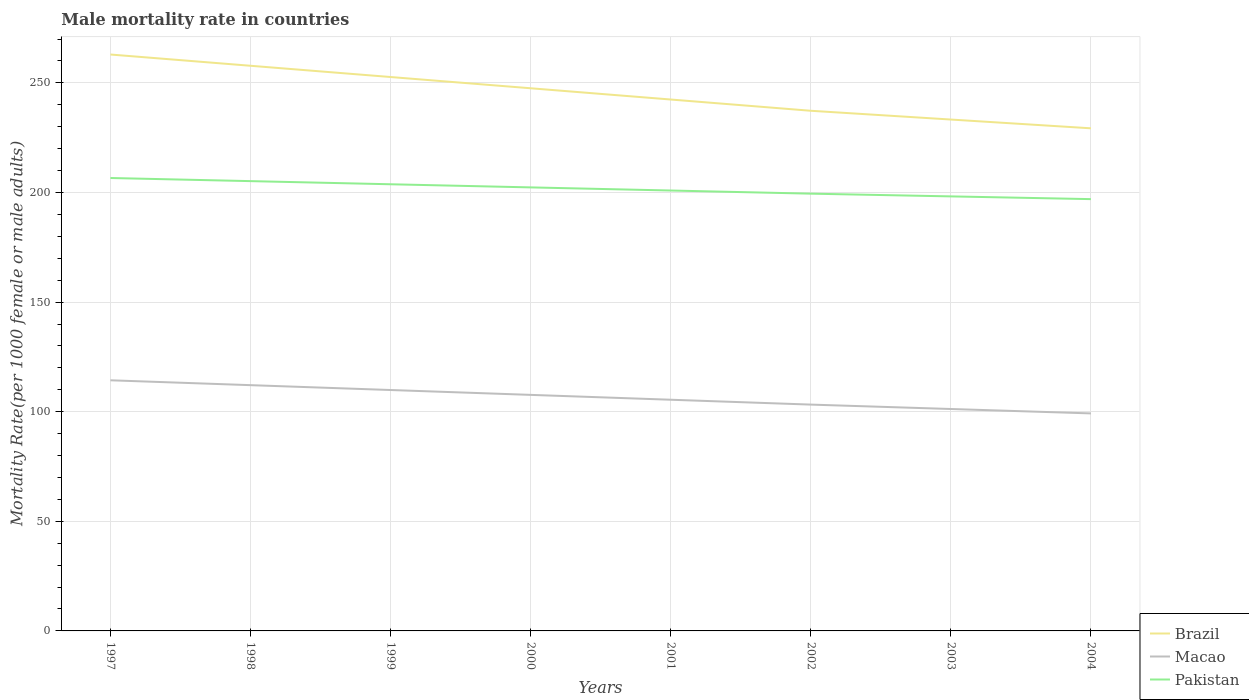Across all years, what is the maximum male mortality rate in Brazil?
Make the answer very short. 229.27. What is the total male mortality rate in Macao in the graph?
Offer a very short reply. 6.24. What is the difference between the highest and the second highest male mortality rate in Brazil?
Your answer should be very brief. 33.66. Is the male mortality rate in Macao strictly greater than the male mortality rate in Brazil over the years?
Give a very brief answer. Yes. How many lines are there?
Offer a terse response. 3. How many years are there in the graph?
Provide a short and direct response. 8. What is the difference between two consecutive major ticks on the Y-axis?
Provide a short and direct response. 50. Does the graph contain any zero values?
Offer a very short reply. No. Does the graph contain grids?
Ensure brevity in your answer.  Yes. Where does the legend appear in the graph?
Provide a short and direct response. Bottom right. How many legend labels are there?
Your response must be concise. 3. How are the legend labels stacked?
Ensure brevity in your answer.  Vertical. What is the title of the graph?
Provide a succinct answer. Male mortality rate in countries. Does "United Arab Emirates" appear as one of the legend labels in the graph?
Keep it short and to the point. No. What is the label or title of the X-axis?
Keep it short and to the point. Years. What is the label or title of the Y-axis?
Provide a short and direct response. Mortality Rate(per 1000 female or male adults). What is the Mortality Rate(per 1000 female or male adults) of Brazil in 1997?
Provide a short and direct response. 262.93. What is the Mortality Rate(per 1000 female or male adults) of Macao in 1997?
Make the answer very short. 114.33. What is the Mortality Rate(per 1000 female or male adults) in Pakistan in 1997?
Provide a succinct answer. 206.6. What is the Mortality Rate(per 1000 female or male adults) in Brazil in 1998?
Your answer should be compact. 257.79. What is the Mortality Rate(per 1000 female or male adults) of Macao in 1998?
Offer a very short reply. 112.11. What is the Mortality Rate(per 1000 female or male adults) of Pakistan in 1998?
Keep it short and to the point. 205.17. What is the Mortality Rate(per 1000 female or male adults) of Brazil in 1999?
Your answer should be very brief. 252.66. What is the Mortality Rate(per 1000 female or male adults) of Macao in 1999?
Your answer should be very brief. 109.89. What is the Mortality Rate(per 1000 female or male adults) in Pakistan in 1999?
Keep it short and to the point. 203.75. What is the Mortality Rate(per 1000 female or male adults) of Brazil in 2000?
Offer a very short reply. 247.53. What is the Mortality Rate(per 1000 female or male adults) of Macao in 2000?
Your answer should be very brief. 107.67. What is the Mortality Rate(per 1000 female or male adults) in Pakistan in 2000?
Ensure brevity in your answer.  202.32. What is the Mortality Rate(per 1000 female or male adults) of Brazil in 2001?
Your response must be concise. 242.4. What is the Mortality Rate(per 1000 female or male adults) in Macao in 2001?
Your answer should be very brief. 105.46. What is the Mortality Rate(per 1000 female or male adults) of Pakistan in 2001?
Your answer should be very brief. 200.89. What is the Mortality Rate(per 1000 female or male adults) of Brazil in 2002?
Your response must be concise. 237.27. What is the Mortality Rate(per 1000 female or male adults) of Macao in 2002?
Your response must be concise. 103.24. What is the Mortality Rate(per 1000 female or male adults) in Pakistan in 2002?
Offer a terse response. 199.46. What is the Mortality Rate(per 1000 female or male adults) of Brazil in 2003?
Make the answer very short. 233.27. What is the Mortality Rate(per 1000 female or male adults) of Macao in 2003?
Your answer should be very brief. 101.23. What is the Mortality Rate(per 1000 female or male adults) in Pakistan in 2003?
Keep it short and to the point. 198.21. What is the Mortality Rate(per 1000 female or male adults) of Brazil in 2004?
Provide a short and direct response. 229.27. What is the Mortality Rate(per 1000 female or male adults) in Macao in 2004?
Your answer should be very brief. 99.22. What is the Mortality Rate(per 1000 female or male adults) in Pakistan in 2004?
Offer a terse response. 196.97. Across all years, what is the maximum Mortality Rate(per 1000 female or male adults) of Brazil?
Your answer should be very brief. 262.93. Across all years, what is the maximum Mortality Rate(per 1000 female or male adults) in Macao?
Your answer should be compact. 114.33. Across all years, what is the maximum Mortality Rate(per 1000 female or male adults) of Pakistan?
Your response must be concise. 206.6. Across all years, what is the minimum Mortality Rate(per 1000 female or male adults) in Brazil?
Your answer should be very brief. 229.27. Across all years, what is the minimum Mortality Rate(per 1000 female or male adults) in Macao?
Offer a very short reply. 99.22. Across all years, what is the minimum Mortality Rate(per 1000 female or male adults) in Pakistan?
Offer a very short reply. 196.97. What is the total Mortality Rate(per 1000 female or male adults) in Brazil in the graph?
Provide a succinct answer. 1963.11. What is the total Mortality Rate(per 1000 female or male adults) of Macao in the graph?
Offer a very short reply. 853.14. What is the total Mortality Rate(per 1000 female or male adults) of Pakistan in the graph?
Provide a short and direct response. 1613.36. What is the difference between the Mortality Rate(per 1000 female or male adults) in Brazil in 1997 and that in 1998?
Keep it short and to the point. 5.13. What is the difference between the Mortality Rate(per 1000 female or male adults) of Macao in 1997 and that in 1998?
Your answer should be compact. 2.22. What is the difference between the Mortality Rate(per 1000 female or male adults) in Pakistan in 1997 and that in 1998?
Your answer should be compact. 1.43. What is the difference between the Mortality Rate(per 1000 female or male adults) of Brazil in 1997 and that in 1999?
Your answer should be compact. 10.26. What is the difference between the Mortality Rate(per 1000 female or male adults) of Macao in 1997 and that in 1999?
Offer a terse response. 4.43. What is the difference between the Mortality Rate(per 1000 female or male adults) in Pakistan in 1997 and that in 1999?
Your answer should be very brief. 2.86. What is the difference between the Mortality Rate(per 1000 female or male adults) of Brazil in 1997 and that in 2000?
Offer a terse response. 15.39. What is the difference between the Mortality Rate(per 1000 female or male adults) of Macao in 1997 and that in 2000?
Offer a very short reply. 6.65. What is the difference between the Mortality Rate(per 1000 female or male adults) in Pakistan in 1997 and that in 2000?
Your answer should be very brief. 4.28. What is the difference between the Mortality Rate(per 1000 female or male adults) of Brazil in 1997 and that in 2001?
Your answer should be compact. 20.53. What is the difference between the Mortality Rate(per 1000 female or male adults) in Macao in 1997 and that in 2001?
Provide a succinct answer. 8.87. What is the difference between the Mortality Rate(per 1000 female or male adults) of Pakistan in 1997 and that in 2001?
Your answer should be very brief. 5.71. What is the difference between the Mortality Rate(per 1000 female or male adults) of Brazil in 1997 and that in 2002?
Your answer should be compact. 25.66. What is the difference between the Mortality Rate(per 1000 female or male adults) in Macao in 1997 and that in 2002?
Offer a terse response. 11.09. What is the difference between the Mortality Rate(per 1000 female or male adults) in Pakistan in 1997 and that in 2002?
Make the answer very short. 7.14. What is the difference between the Mortality Rate(per 1000 female or male adults) of Brazil in 1997 and that in 2003?
Offer a very short reply. 29.66. What is the difference between the Mortality Rate(per 1000 female or male adults) in Macao in 1997 and that in 2003?
Make the answer very short. 13.1. What is the difference between the Mortality Rate(per 1000 female or male adults) of Pakistan in 1997 and that in 2003?
Your answer should be compact. 8.39. What is the difference between the Mortality Rate(per 1000 female or male adults) of Brazil in 1997 and that in 2004?
Offer a terse response. 33.66. What is the difference between the Mortality Rate(per 1000 female or male adults) in Macao in 1997 and that in 2004?
Give a very brief answer. 15.11. What is the difference between the Mortality Rate(per 1000 female or male adults) in Pakistan in 1997 and that in 2004?
Make the answer very short. 9.64. What is the difference between the Mortality Rate(per 1000 female or male adults) of Brazil in 1998 and that in 1999?
Provide a succinct answer. 5.13. What is the difference between the Mortality Rate(per 1000 female or male adults) of Macao in 1998 and that in 1999?
Offer a very short reply. 2.22. What is the difference between the Mortality Rate(per 1000 female or male adults) in Pakistan in 1998 and that in 1999?
Provide a succinct answer. 1.43. What is the difference between the Mortality Rate(per 1000 female or male adults) of Brazil in 1998 and that in 2000?
Give a very brief answer. 10.26. What is the difference between the Mortality Rate(per 1000 female or male adults) in Macao in 1998 and that in 2000?
Offer a very short reply. 4.43. What is the difference between the Mortality Rate(per 1000 female or male adults) in Pakistan in 1998 and that in 2000?
Provide a short and direct response. 2.86. What is the difference between the Mortality Rate(per 1000 female or male adults) in Brazil in 1998 and that in 2001?
Offer a terse response. 15.39. What is the difference between the Mortality Rate(per 1000 female or male adults) of Macao in 1998 and that in 2001?
Your answer should be compact. 6.65. What is the difference between the Mortality Rate(per 1000 female or male adults) in Pakistan in 1998 and that in 2001?
Your answer should be compact. 4.28. What is the difference between the Mortality Rate(per 1000 female or male adults) of Brazil in 1998 and that in 2002?
Offer a terse response. 20.53. What is the difference between the Mortality Rate(per 1000 female or male adults) of Macao in 1998 and that in 2002?
Offer a terse response. 8.87. What is the difference between the Mortality Rate(per 1000 female or male adults) of Pakistan in 1998 and that in 2002?
Ensure brevity in your answer.  5.71. What is the difference between the Mortality Rate(per 1000 female or male adults) in Brazil in 1998 and that in 2003?
Ensure brevity in your answer.  24.53. What is the difference between the Mortality Rate(per 1000 female or male adults) of Macao in 1998 and that in 2003?
Your answer should be compact. 10.88. What is the difference between the Mortality Rate(per 1000 female or male adults) in Pakistan in 1998 and that in 2003?
Ensure brevity in your answer.  6.96. What is the difference between the Mortality Rate(per 1000 female or male adults) of Brazil in 1998 and that in 2004?
Keep it short and to the point. 28.53. What is the difference between the Mortality Rate(per 1000 female or male adults) in Macao in 1998 and that in 2004?
Provide a short and direct response. 12.89. What is the difference between the Mortality Rate(per 1000 female or male adults) of Pakistan in 1998 and that in 2004?
Offer a terse response. 8.21. What is the difference between the Mortality Rate(per 1000 female or male adults) in Brazil in 1999 and that in 2000?
Your answer should be compact. 5.13. What is the difference between the Mortality Rate(per 1000 female or male adults) of Macao in 1999 and that in 2000?
Your answer should be compact. 2.22. What is the difference between the Mortality Rate(per 1000 female or male adults) in Pakistan in 1999 and that in 2000?
Offer a terse response. 1.43. What is the difference between the Mortality Rate(per 1000 female or male adults) of Brazil in 1999 and that in 2001?
Your response must be concise. 10.26. What is the difference between the Mortality Rate(per 1000 female or male adults) in Macao in 1999 and that in 2001?
Offer a terse response. 4.43. What is the difference between the Mortality Rate(per 1000 female or male adults) in Pakistan in 1999 and that in 2001?
Your response must be concise. 2.86. What is the difference between the Mortality Rate(per 1000 female or male adults) of Brazil in 1999 and that in 2002?
Your response must be concise. 15.39. What is the difference between the Mortality Rate(per 1000 female or male adults) in Macao in 1999 and that in 2002?
Offer a very short reply. 6.65. What is the difference between the Mortality Rate(per 1000 female or male adults) in Pakistan in 1999 and that in 2002?
Give a very brief answer. 4.28. What is the difference between the Mortality Rate(per 1000 female or male adults) in Brazil in 1999 and that in 2003?
Keep it short and to the point. 19.39. What is the difference between the Mortality Rate(per 1000 female or male adults) of Macao in 1999 and that in 2003?
Keep it short and to the point. 8.66. What is the difference between the Mortality Rate(per 1000 female or male adults) in Pakistan in 1999 and that in 2003?
Offer a terse response. 5.53. What is the difference between the Mortality Rate(per 1000 female or male adults) in Brazil in 1999 and that in 2004?
Provide a succinct answer. 23.39. What is the difference between the Mortality Rate(per 1000 female or male adults) in Macao in 1999 and that in 2004?
Offer a very short reply. 10.67. What is the difference between the Mortality Rate(per 1000 female or male adults) of Pakistan in 1999 and that in 2004?
Ensure brevity in your answer.  6.78. What is the difference between the Mortality Rate(per 1000 female or male adults) in Brazil in 2000 and that in 2001?
Make the answer very short. 5.13. What is the difference between the Mortality Rate(per 1000 female or male adults) in Macao in 2000 and that in 2001?
Your answer should be compact. 2.22. What is the difference between the Mortality Rate(per 1000 female or male adults) in Pakistan in 2000 and that in 2001?
Give a very brief answer. 1.43. What is the difference between the Mortality Rate(per 1000 female or male adults) of Brazil in 2000 and that in 2002?
Make the answer very short. 10.26. What is the difference between the Mortality Rate(per 1000 female or male adults) of Macao in 2000 and that in 2002?
Offer a very short reply. 4.43. What is the difference between the Mortality Rate(per 1000 female or male adults) in Pakistan in 2000 and that in 2002?
Provide a short and direct response. 2.86. What is the difference between the Mortality Rate(per 1000 female or male adults) of Brazil in 2000 and that in 2003?
Provide a succinct answer. 14.26. What is the difference between the Mortality Rate(per 1000 female or male adults) of Macao in 2000 and that in 2003?
Provide a succinct answer. 6.45. What is the difference between the Mortality Rate(per 1000 female or male adults) of Pakistan in 2000 and that in 2003?
Provide a succinct answer. 4.1. What is the difference between the Mortality Rate(per 1000 female or male adults) in Brazil in 2000 and that in 2004?
Keep it short and to the point. 18.26. What is the difference between the Mortality Rate(per 1000 female or male adults) of Macao in 2000 and that in 2004?
Keep it short and to the point. 8.46. What is the difference between the Mortality Rate(per 1000 female or male adults) of Pakistan in 2000 and that in 2004?
Make the answer very short. 5.35. What is the difference between the Mortality Rate(per 1000 female or male adults) in Brazil in 2001 and that in 2002?
Provide a short and direct response. 5.13. What is the difference between the Mortality Rate(per 1000 female or male adults) of Macao in 2001 and that in 2002?
Your response must be concise. 2.22. What is the difference between the Mortality Rate(per 1000 female or male adults) in Pakistan in 2001 and that in 2002?
Offer a very short reply. 1.43. What is the difference between the Mortality Rate(per 1000 female or male adults) of Brazil in 2001 and that in 2003?
Your answer should be compact. 9.13. What is the difference between the Mortality Rate(per 1000 female or male adults) in Macao in 2001 and that in 2003?
Give a very brief answer. 4.23. What is the difference between the Mortality Rate(per 1000 female or male adults) in Pakistan in 2001 and that in 2003?
Your response must be concise. 2.68. What is the difference between the Mortality Rate(per 1000 female or male adults) of Brazil in 2001 and that in 2004?
Your response must be concise. 13.13. What is the difference between the Mortality Rate(per 1000 female or male adults) in Macao in 2001 and that in 2004?
Provide a succinct answer. 6.24. What is the difference between the Mortality Rate(per 1000 female or male adults) of Pakistan in 2001 and that in 2004?
Make the answer very short. 3.92. What is the difference between the Mortality Rate(per 1000 female or male adults) in Macao in 2002 and that in 2003?
Offer a very short reply. 2.01. What is the difference between the Mortality Rate(per 1000 female or male adults) in Pakistan in 2002 and that in 2003?
Make the answer very short. 1.25. What is the difference between the Mortality Rate(per 1000 female or male adults) in Macao in 2002 and that in 2004?
Provide a short and direct response. 4.02. What is the difference between the Mortality Rate(per 1000 female or male adults) of Pakistan in 2002 and that in 2004?
Offer a terse response. 2.5. What is the difference between the Mortality Rate(per 1000 female or male adults) in Brazil in 2003 and that in 2004?
Ensure brevity in your answer.  4. What is the difference between the Mortality Rate(per 1000 female or male adults) in Macao in 2003 and that in 2004?
Offer a very short reply. 2.01. What is the difference between the Mortality Rate(per 1000 female or male adults) in Pakistan in 2003 and that in 2004?
Ensure brevity in your answer.  1.25. What is the difference between the Mortality Rate(per 1000 female or male adults) of Brazil in 1997 and the Mortality Rate(per 1000 female or male adults) of Macao in 1998?
Offer a very short reply. 150.82. What is the difference between the Mortality Rate(per 1000 female or male adults) of Brazil in 1997 and the Mortality Rate(per 1000 female or male adults) of Pakistan in 1998?
Ensure brevity in your answer.  57.75. What is the difference between the Mortality Rate(per 1000 female or male adults) of Macao in 1997 and the Mortality Rate(per 1000 female or male adults) of Pakistan in 1998?
Provide a short and direct response. -90.85. What is the difference between the Mortality Rate(per 1000 female or male adults) in Brazil in 1997 and the Mortality Rate(per 1000 female or male adults) in Macao in 1999?
Ensure brevity in your answer.  153.03. What is the difference between the Mortality Rate(per 1000 female or male adults) of Brazil in 1997 and the Mortality Rate(per 1000 female or male adults) of Pakistan in 1999?
Your answer should be very brief. 59.18. What is the difference between the Mortality Rate(per 1000 female or male adults) of Macao in 1997 and the Mortality Rate(per 1000 female or male adults) of Pakistan in 1999?
Your response must be concise. -89.42. What is the difference between the Mortality Rate(per 1000 female or male adults) of Brazil in 1997 and the Mortality Rate(per 1000 female or male adults) of Macao in 2000?
Give a very brief answer. 155.25. What is the difference between the Mortality Rate(per 1000 female or male adults) in Brazil in 1997 and the Mortality Rate(per 1000 female or male adults) in Pakistan in 2000?
Provide a short and direct response. 60.61. What is the difference between the Mortality Rate(per 1000 female or male adults) of Macao in 1997 and the Mortality Rate(per 1000 female or male adults) of Pakistan in 2000?
Provide a short and direct response. -87.99. What is the difference between the Mortality Rate(per 1000 female or male adults) of Brazil in 1997 and the Mortality Rate(per 1000 female or male adults) of Macao in 2001?
Your answer should be very brief. 157.47. What is the difference between the Mortality Rate(per 1000 female or male adults) in Brazil in 1997 and the Mortality Rate(per 1000 female or male adults) in Pakistan in 2001?
Give a very brief answer. 62.04. What is the difference between the Mortality Rate(per 1000 female or male adults) in Macao in 1997 and the Mortality Rate(per 1000 female or male adults) in Pakistan in 2001?
Make the answer very short. -86.56. What is the difference between the Mortality Rate(per 1000 female or male adults) of Brazil in 1997 and the Mortality Rate(per 1000 female or male adults) of Macao in 2002?
Make the answer very short. 159.69. What is the difference between the Mortality Rate(per 1000 female or male adults) in Brazil in 1997 and the Mortality Rate(per 1000 female or male adults) in Pakistan in 2002?
Your answer should be very brief. 63.47. What is the difference between the Mortality Rate(per 1000 female or male adults) in Macao in 1997 and the Mortality Rate(per 1000 female or male adults) in Pakistan in 2002?
Give a very brief answer. -85.14. What is the difference between the Mortality Rate(per 1000 female or male adults) of Brazil in 1997 and the Mortality Rate(per 1000 female or male adults) of Macao in 2003?
Offer a terse response. 161.7. What is the difference between the Mortality Rate(per 1000 female or male adults) of Brazil in 1997 and the Mortality Rate(per 1000 female or male adults) of Pakistan in 2003?
Your answer should be compact. 64.71. What is the difference between the Mortality Rate(per 1000 female or male adults) of Macao in 1997 and the Mortality Rate(per 1000 female or male adults) of Pakistan in 2003?
Provide a short and direct response. -83.89. What is the difference between the Mortality Rate(per 1000 female or male adults) in Brazil in 1997 and the Mortality Rate(per 1000 female or male adults) in Macao in 2004?
Give a very brief answer. 163.71. What is the difference between the Mortality Rate(per 1000 female or male adults) of Brazil in 1997 and the Mortality Rate(per 1000 female or male adults) of Pakistan in 2004?
Provide a short and direct response. 65.96. What is the difference between the Mortality Rate(per 1000 female or male adults) in Macao in 1997 and the Mortality Rate(per 1000 female or male adults) in Pakistan in 2004?
Provide a short and direct response. -82.64. What is the difference between the Mortality Rate(per 1000 female or male adults) in Brazil in 1998 and the Mortality Rate(per 1000 female or male adults) in Macao in 1999?
Make the answer very short. 147.9. What is the difference between the Mortality Rate(per 1000 female or male adults) in Brazil in 1998 and the Mortality Rate(per 1000 female or male adults) in Pakistan in 1999?
Ensure brevity in your answer.  54.05. What is the difference between the Mortality Rate(per 1000 female or male adults) of Macao in 1998 and the Mortality Rate(per 1000 female or male adults) of Pakistan in 1999?
Offer a terse response. -91.64. What is the difference between the Mortality Rate(per 1000 female or male adults) of Brazil in 1998 and the Mortality Rate(per 1000 female or male adults) of Macao in 2000?
Offer a very short reply. 150.12. What is the difference between the Mortality Rate(per 1000 female or male adults) in Brazil in 1998 and the Mortality Rate(per 1000 female or male adults) in Pakistan in 2000?
Your response must be concise. 55.48. What is the difference between the Mortality Rate(per 1000 female or male adults) of Macao in 1998 and the Mortality Rate(per 1000 female or male adults) of Pakistan in 2000?
Keep it short and to the point. -90.21. What is the difference between the Mortality Rate(per 1000 female or male adults) of Brazil in 1998 and the Mortality Rate(per 1000 female or male adults) of Macao in 2001?
Offer a very short reply. 152.34. What is the difference between the Mortality Rate(per 1000 female or male adults) in Brazil in 1998 and the Mortality Rate(per 1000 female or male adults) in Pakistan in 2001?
Provide a short and direct response. 56.91. What is the difference between the Mortality Rate(per 1000 female or male adults) in Macao in 1998 and the Mortality Rate(per 1000 female or male adults) in Pakistan in 2001?
Give a very brief answer. -88.78. What is the difference between the Mortality Rate(per 1000 female or male adults) of Brazil in 1998 and the Mortality Rate(per 1000 female or male adults) of Macao in 2002?
Provide a succinct answer. 154.56. What is the difference between the Mortality Rate(per 1000 female or male adults) of Brazil in 1998 and the Mortality Rate(per 1000 female or male adults) of Pakistan in 2002?
Provide a short and direct response. 58.33. What is the difference between the Mortality Rate(per 1000 female or male adults) of Macao in 1998 and the Mortality Rate(per 1000 female or male adults) of Pakistan in 2002?
Offer a terse response. -87.35. What is the difference between the Mortality Rate(per 1000 female or male adults) in Brazil in 1998 and the Mortality Rate(per 1000 female or male adults) in Macao in 2003?
Your answer should be compact. 156.56. What is the difference between the Mortality Rate(per 1000 female or male adults) in Brazil in 1998 and the Mortality Rate(per 1000 female or male adults) in Pakistan in 2003?
Your response must be concise. 59.58. What is the difference between the Mortality Rate(per 1000 female or male adults) in Macao in 1998 and the Mortality Rate(per 1000 female or male adults) in Pakistan in 2003?
Provide a succinct answer. -86.1. What is the difference between the Mortality Rate(per 1000 female or male adults) in Brazil in 1998 and the Mortality Rate(per 1000 female or male adults) in Macao in 2004?
Keep it short and to the point. 158.57. What is the difference between the Mortality Rate(per 1000 female or male adults) of Brazil in 1998 and the Mortality Rate(per 1000 female or male adults) of Pakistan in 2004?
Offer a terse response. 60.83. What is the difference between the Mortality Rate(per 1000 female or male adults) of Macao in 1998 and the Mortality Rate(per 1000 female or male adults) of Pakistan in 2004?
Provide a succinct answer. -84.86. What is the difference between the Mortality Rate(per 1000 female or male adults) of Brazil in 1999 and the Mortality Rate(per 1000 female or male adults) of Macao in 2000?
Provide a short and direct response. 144.99. What is the difference between the Mortality Rate(per 1000 female or male adults) of Brazil in 1999 and the Mortality Rate(per 1000 female or male adults) of Pakistan in 2000?
Give a very brief answer. 50.34. What is the difference between the Mortality Rate(per 1000 female or male adults) in Macao in 1999 and the Mortality Rate(per 1000 female or male adults) in Pakistan in 2000?
Provide a short and direct response. -92.43. What is the difference between the Mortality Rate(per 1000 female or male adults) in Brazil in 1999 and the Mortality Rate(per 1000 female or male adults) in Macao in 2001?
Give a very brief answer. 147.21. What is the difference between the Mortality Rate(per 1000 female or male adults) in Brazil in 1999 and the Mortality Rate(per 1000 female or male adults) in Pakistan in 2001?
Give a very brief answer. 51.77. What is the difference between the Mortality Rate(per 1000 female or male adults) of Macao in 1999 and the Mortality Rate(per 1000 female or male adults) of Pakistan in 2001?
Provide a short and direct response. -91. What is the difference between the Mortality Rate(per 1000 female or male adults) in Brazil in 1999 and the Mortality Rate(per 1000 female or male adults) in Macao in 2002?
Make the answer very short. 149.42. What is the difference between the Mortality Rate(per 1000 female or male adults) of Brazil in 1999 and the Mortality Rate(per 1000 female or male adults) of Pakistan in 2002?
Your response must be concise. 53.2. What is the difference between the Mortality Rate(per 1000 female or male adults) in Macao in 1999 and the Mortality Rate(per 1000 female or male adults) in Pakistan in 2002?
Give a very brief answer. -89.57. What is the difference between the Mortality Rate(per 1000 female or male adults) in Brazil in 1999 and the Mortality Rate(per 1000 female or male adults) in Macao in 2003?
Give a very brief answer. 151.43. What is the difference between the Mortality Rate(per 1000 female or male adults) of Brazil in 1999 and the Mortality Rate(per 1000 female or male adults) of Pakistan in 2003?
Offer a very short reply. 54.45. What is the difference between the Mortality Rate(per 1000 female or male adults) of Macao in 1999 and the Mortality Rate(per 1000 female or male adults) of Pakistan in 2003?
Offer a very short reply. -88.32. What is the difference between the Mortality Rate(per 1000 female or male adults) in Brazil in 1999 and the Mortality Rate(per 1000 female or male adults) in Macao in 2004?
Give a very brief answer. 153.44. What is the difference between the Mortality Rate(per 1000 female or male adults) of Brazil in 1999 and the Mortality Rate(per 1000 female or male adults) of Pakistan in 2004?
Keep it short and to the point. 55.7. What is the difference between the Mortality Rate(per 1000 female or male adults) of Macao in 1999 and the Mortality Rate(per 1000 female or male adults) of Pakistan in 2004?
Give a very brief answer. -87.07. What is the difference between the Mortality Rate(per 1000 female or male adults) of Brazil in 2000 and the Mortality Rate(per 1000 female or male adults) of Macao in 2001?
Your answer should be compact. 142.07. What is the difference between the Mortality Rate(per 1000 female or male adults) of Brazil in 2000 and the Mortality Rate(per 1000 female or male adults) of Pakistan in 2001?
Give a very brief answer. 46.64. What is the difference between the Mortality Rate(per 1000 female or male adults) of Macao in 2000 and the Mortality Rate(per 1000 female or male adults) of Pakistan in 2001?
Give a very brief answer. -93.22. What is the difference between the Mortality Rate(per 1000 female or male adults) of Brazil in 2000 and the Mortality Rate(per 1000 female or male adults) of Macao in 2002?
Offer a very short reply. 144.29. What is the difference between the Mortality Rate(per 1000 female or male adults) of Brazil in 2000 and the Mortality Rate(per 1000 female or male adults) of Pakistan in 2002?
Ensure brevity in your answer.  48.07. What is the difference between the Mortality Rate(per 1000 female or male adults) in Macao in 2000 and the Mortality Rate(per 1000 female or male adults) in Pakistan in 2002?
Provide a succinct answer. -91.79. What is the difference between the Mortality Rate(per 1000 female or male adults) of Brazil in 2000 and the Mortality Rate(per 1000 female or male adults) of Macao in 2003?
Make the answer very short. 146.3. What is the difference between the Mortality Rate(per 1000 female or male adults) of Brazil in 2000 and the Mortality Rate(per 1000 female or male adults) of Pakistan in 2003?
Make the answer very short. 49.32. What is the difference between the Mortality Rate(per 1000 female or male adults) of Macao in 2000 and the Mortality Rate(per 1000 female or male adults) of Pakistan in 2003?
Offer a terse response. -90.54. What is the difference between the Mortality Rate(per 1000 female or male adults) in Brazil in 2000 and the Mortality Rate(per 1000 female or male adults) in Macao in 2004?
Your answer should be very brief. 148.31. What is the difference between the Mortality Rate(per 1000 female or male adults) of Brazil in 2000 and the Mortality Rate(per 1000 female or male adults) of Pakistan in 2004?
Your answer should be compact. 50.57. What is the difference between the Mortality Rate(per 1000 female or male adults) of Macao in 2000 and the Mortality Rate(per 1000 female or male adults) of Pakistan in 2004?
Offer a very short reply. -89.29. What is the difference between the Mortality Rate(per 1000 female or male adults) of Brazil in 2001 and the Mortality Rate(per 1000 female or male adults) of Macao in 2002?
Ensure brevity in your answer.  139.16. What is the difference between the Mortality Rate(per 1000 female or male adults) in Brazil in 2001 and the Mortality Rate(per 1000 female or male adults) in Pakistan in 2002?
Provide a short and direct response. 42.94. What is the difference between the Mortality Rate(per 1000 female or male adults) of Macao in 2001 and the Mortality Rate(per 1000 female or male adults) of Pakistan in 2002?
Offer a very short reply. -94. What is the difference between the Mortality Rate(per 1000 female or male adults) of Brazil in 2001 and the Mortality Rate(per 1000 female or male adults) of Macao in 2003?
Give a very brief answer. 141.17. What is the difference between the Mortality Rate(per 1000 female or male adults) in Brazil in 2001 and the Mortality Rate(per 1000 female or male adults) in Pakistan in 2003?
Your answer should be very brief. 44.19. What is the difference between the Mortality Rate(per 1000 female or male adults) in Macao in 2001 and the Mortality Rate(per 1000 female or male adults) in Pakistan in 2003?
Give a very brief answer. -92.76. What is the difference between the Mortality Rate(per 1000 female or male adults) of Brazil in 2001 and the Mortality Rate(per 1000 female or male adults) of Macao in 2004?
Your answer should be very brief. 143.18. What is the difference between the Mortality Rate(per 1000 female or male adults) of Brazil in 2001 and the Mortality Rate(per 1000 female or male adults) of Pakistan in 2004?
Give a very brief answer. 45.43. What is the difference between the Mortality Rate(per 1000 female or male adults) of Macao in 2001 and the Mortality Rate(per 1000 female or male adults) of Pakistan in 2004?
Give a very brief answer. -91.51. What is the difference between the Mortality Rate(per 1000 female or male adults) of Brazil in 2002 and the Mortality Rate(per 1000 female or male adults) of Macao in 2003?
Your answer should be very brief. 136.04. What is the difference between the Mortality Rate(per 1000 female or male adults) of Brazil in 2002 and the Mortality Rate(per 1000 female or male adults) of Pakistan in 2003?
Your response must be concise. 39.05. What is the difference between the Mortality Rate(per 1000 female or male adults) in Macao in 2002 and the Mortality Rate(per 1000 female or male adults) in Pakistan in 2003?
Offer a very short reply. -94.97. What is the difference between the Mortality Rate(per 1000 female or male adults) of Brazil in 2002 and the Mortality Rate(per 1000 female or male adults) of Macao in 2004?
Provide a succinct answer. 138.05. What is the difference between the Mortality Rate(per 1000 female or male adults) of Brazil in 2002 and the Mortality Rate(per 1000 female or male adults) of Pakistan in 2004?
Ensure brevity in your answer.  40.3. What is the difference between the Mortality Rate(per 1000 female or male adults) in Macao in 2002 and the Mortality Rate(per 1000 female or male adults) in Pakistan in 2004?
Your response must be concise. -93.73. What is the difference between the Mortality Rate(per 1000 female or male adults) in Brazil in 2003 and the Mortality Rate(per 1000 female or male adults) in Macao in 2004?
Ensure brevity in your answer.  134.05. What is the difference between the Mortality Rate(per 1000 female or male adults) of Brazil in 2003 and the Mortality Rate(per 1000 female or male adults) of Pakistan in 2004?
Your response must be concise. 36.3. What is the difference between the Mortality Rate(per 1000 female or male adults) of Macao in 2003 and the Mortality Rate(per 1000 female or male adults) of Pakistan in 2004?
Make the answer very short. -95.74. What is the average Mortality Rate(per 1000 female or male adults) in Brazil per year?
Provide a succinct answer. 245.39. What is the average Mortality Rate(per 1000 female or male adults) of Macao per year?
Give a very brief answer. 106.64. What is the average Mortality Rate(per 1000 female or male adults) in Pakistan per year?
Give a very brief answer. 201.67. In the year 1997, what is the difference between the Mortality Rate(per 1000 female or male adults) in Brazil and Mortality Rate(per 1000 female or male adults) in Macao?
Your response must be concise. 148.6. In the year 1997, what is the difference between the Mortality Rate(per 1000 female or male adults) of Brazil and Mortality Rate(per 1000 female or male adults) of Pakistan?
Offer a very short reply. 56.33. In the year 1997, what is the difference between the Mortality Rate(per 1000 female or male adults) of Macao and Mortality Rate(per 1000 female or male adults) of Pakistan?
Offer a very short reply. -92.28. In the year 1998, what is the difference between the Mortality Rate(per 1000 female or male adults) of Brazil and Mortality Rate(per 1000 female or male adults) of Macao?
Offer a terse response. 145.69. In the year 1998, what is the difference between the Mortality Rate(per 1000 female or male adults) of Brazil and Mortality Rate(per 1000 female or male adults) of Pakistan?
Provide a succinct answer. 52.62. In the year 1998, what is the difference between the Mortality Rate(per 1000 female or male adults) of Macao and Mortality Rate(per 1000 female or male adults) of Pakistan?
Your answer should be compact. -93.06. In the year 1999, what is the difference between the Mortality Rate(per 1000 female or male adults) of Brazil and Mortality Rate(per 1000 female or male adults) of Macao?
Keep it short and to the point. 142.77. In the year 1999, what is the difference between the Mortality Rate(per 1000 female or male adults) of Brazil and Mortality Rate(per 1000 female or male adults) of Pakistan?
Keep it short and to the point. 48.92. In the year 1999, what is the difference between the Mortality Rate(per 1000 female or male adults) of Macao and Mortality Rate(per 1000 female or male adults) of Pakistan?
Keep it short and to the point. -93.85. In the year 2000, what is the difference between the Mortality Rate(per 1000 female or male adults) in Brazil and Mortality Rate(per 1000 female or male adults) in Macao?
Give a very brief answer. 139.86. In the year 2000, what is the difference between the Mortality Rate(per 1000 female or male adults) of Brazil and Mortality Rate(per 1000 female or male adults) of Pakistan?
Your answer should be very brief. 45.21. In the year 2000, what is the difference between the Mortality Rate(per 1000 female or male adults) of Macao and Mortality Rate(per 1000 female or male adults) of Pakistan?
Provide a succinct answer. -94.64. In the year 2001, what is the difference between the Mortality Rate(per 1000 female or male adults) in Brazil and Mortality Rate(per 1000 female or male adults) in Macao?
Your response must be concise. 136.94. In the year 2001, what is the difference between the Mortality Rate(per 1000 female or male adults) of Brazil and Mortality Rate(per 1000 female or male adults) of Pakistan?
Ensure brevity in your answer.  41.51. In the year 2001, what is the difference between the Mortality Rate(per 1000 female or male adults) in Macao and Mortality Rate(per 1000 female or male adults) in Pakistan?
Make the answer very short. -95.43. In the year 2002, what is the difference between the Mortality Rate(per 1000 female or male adults) in Brazil and Mortality Rate(per 1000 female or male adults) in Macao?
Provide a short and direct response. 134.03. In the year 2002, what is the difference between the Mortality Rate(per 1000 female or male adults) in Brazil and Mortality Rate(per 1000 female or male adults) in Pakistan?
Give a very brief answer. 37.81. In the year 2002, what is the difference between the Mortality Rate(per 1000 female or male adults) in Macao and Mortality Rate(per 1000 female or male adults) in Pakistan?
Ensure brevity in your answer.  -96.22. In the year 2003, what is the difference between the Mortality Rate(per 1000 female or male adults) in Brazil and Mortality Rate(per 1000 female or male adults) in Macao?
Provide a short and direct response. 132.04. In the year 2003, what is the difference between the Mortality Rate(per 1000 female or male adults) of Brazil and Mortality Rate(per 1000 female or male adults) of Pakistan?
Ensure brevity in your answer.  35.05. In the year 2003, what is the difference between the Mortality Rate(per 1000 female or male adults) of Macao and Mortality Rate(per 1000 female or male adults) of Pakistan?
Your response must be concise. -96.98. In the year 2004, what is the difference between the Mortality Rate(per 1000 female or male adults) in Brazil and Mortality Rate(per 1000 female or male adults) in Macao?
Give a very brief answer. 130.05. In the year 2004, what is the difference between the Mortality Rate(per 1000 female or male adults) of Brazil and Mortality Rate(per 1000 female or male adults) of Pakistan?
Offer a terse response. 32.3. In the year 2004, what is the difference between the Mortality Rate(per 1000 female or male adults) of Macao and Mortality Rate(per 1000 female or male adults) of Pakistan?
Provide a succinct answer. -97.75. What is the ratio of the Mortality Rate(per 1000 female or male adults) in Brazil in 1997 to that in 1998?
Your answer should be very brief. 1.02. What is the ratio of the Mortality Rate(per 1000 female or male adults) of Macao in 1997 to that in 1998?
Your answer should be very brief. 1.02. What is the ratio of the Mortality Rate(per 1000 female or male adults) in Pakistan in 1997 to that in 1998?
Offer a very short reply. 1.01. What is the ratio of the Mortality Rate(per 1000 female or male adults) in Brazil in 1997 to that in 1999?
Offer a very short reply. 1.04. What is the ratio of the Mortality Rate(per 1000 female or male adults) in Macao in 1997 to that in 1999?
Ensure brevity in your answer.  1.04. What is the ratio of the Mortality Rate(per 1000 female or male adults) in Pakistan in 1997 to that in 1999?
Keep it short and to the point. 1.01. What is the ratio of the Mortality Rate(per 1000 female or male adults) of Brazil in 1997 to that in 2000?
Provide a succinct answer. 1.06. What is the ratio of the Mortality Rate(per 1000 female or male adults) of Macao in 1997 to that in 2000?
Give a very brief answer. 1.06. What is the ratio of the Mortality Rate(per 1000 female or male adults) of Pakistan in 1997 to that in 2000?
Your answer should be very brief. 1.02. What is the ratio of the Mortality Rate(per 1000 female or male adults) of Brazil in 1997 to that in 2001?
Ensure brevity in your answer.  1.08. What is the ratio of the Mortality Rate(per 1000 female or male adults) of Macao in 1997 to that in 2001?
Offer a very short reply. 1.08. What is the ratio of the Mortality Rate(per 1000 female or male adults) in Pakistan in 1997 to that in 2001?
Ensure brevity in your answer.  1.03. What is the ratio of the Mortality Rate(per 1000 female or male adults) of Brazil in 1997 to that in 2002?
Keep it short and to the point. 1.11. What is the ratio of the Mortality Rate(per 1000 female or male adults) of Macao in 1997 to that in 2002?
Your answer should be compact. 1.11. What is the ratio of the Mortality Rate(per 1000 female or male adults) of Pakistan in 1997 to that in 2002?
Ensure brevity in your answer.  1.04. What is the ratio of the Mortality Rate(per 1000 female or male adults) of Brazil in 1997 to that in 2003?
Offer a very short reply. 1.13. What is the ratio of the Mortality Rate(per 1000 female or male adults) of Macao in 1997 to that in 2003?
Give a very brief answer. 1.13. What is the ratio of the Mortality Rate(per 1000 female or male adults) of Pakistan in 1997 to that in 2003?
Give a very brief answer. 1.04. What is the ratio of the Mortality Rate(per 1000 female or male adults) of Brazil in 1997 to that in 2004?
Provide a succinct answer. 1.15. What is the ratio of the Mortality Rate(per 1000 female or male adults) in Macao in 1997 to that in 2004?
Give a very brief answer. 1.15. What is the ratio of the Mortality Rate(per 1000 female or male adults) in Pakistan in 1997 to that in 2004?
Your answer should be very brief. 1.05. What is the ratio of the Mortality Rate(per 1000 female or male adults) in Brazil in 1998 to that in 1999?
Your answer should be compact. 1.02. What is the ratio of the Mortality Rate(per 1000 female or male adults) of Macao in 1998 to that in 1999?
Offer a terse response. 1.02. What is the ratio of the Mortality Rate(per 1000 female or male adults) in Brazil in 1998 to that in 2000?
Provide a short and direct response. 1.04. What is the ratio of the Mortality Rate(per 1000 female or male adults) in Macao in 1998 to that in 2000?
Provide a short and direct response. 1.04. What is the ratio of the Mortality Rate(per 1000 female or male adults) of Pakistan in 1998 to that in 2000?
Offer a very short reply. 1.01. What is the ratio of the Mortality Rate(per 1000 female or male adults) of Brazil in 1998 to that in 2001?
Your response must be concise. 1.06. What is the ratio of the Mortality Rate(per 1000 female or male adults) of Macao in 1998 to that in 2001?
Keep it short and to the point. 1.06. What is the ratio of the Mortality Rate(per 1000 female or male adults) of Pakistan in 1998 to that in 2001?
Give a very brief answer. 1.02. What is the ratio of the Mortality Rate(per 1000 female or male adults) of Brazil in 1998 to that in 2002?
Your answer should be very brief. 1.09. What is the ratio of the Mortality Rate(per 1000 female or male adults) in Macao in 1998 to that in 2002?
Provide a short and direct response. 1.09. What is the ratio of the Mortality Rate(per 1000 female or male adults) in Pakistan in 1998 to that in 2002?
Offer a terse response. 1.03. What is the ratio of the Mortality Rate(per 1000 female or male adults) in Brazil in 1998 to that in 2003?
Ensure brevity in your answer.  1.11. What is the ratio of the Mortality Rate(per 1000 female or male adults) of Macao in 1998 to that in 2003?
Your answer should be compact. 1.11. What is the ratio of the Mortality Rate(per 1000 female or male adults) in Pakistan in 1998 to that in 2003?
Ensure brevity in your answer.  1.04. What is the ratio of the Mortality Rate(per 1000 female or male adults) of Brazil in 1998 to that in 2004?
Offer a terse response. 1.12. What is the ratio of the Mortality Rate(per 1000 female or male adults) of Macao in 1998 to that in 2004?
Your response must be concise. 1.13. What is the ratio of the Mortality Rate(per 1000 female or male adults) of Pakistan in 1998 to that in 2004?
Ensure brevity in your answer.  1.04. What is the ratio of the Mortality Rate(per 1000 female or male adults) of Brazil in 1999 to that in 2000?
Offer a terse response. 1.02. What is the ratio of the Mortality Rate(per 1000 female or male adults) in Macao in 1999 to that in 2000?
Make the answer very short. 1.02. What is the ratio of the Mortality Rate(per 1000 female or male adults) in Pakistan in 1999 to that in 2000?
Offer a very short reply. 1.01. What is the ratio of the Mortality Rate(per 1000 female or male adults) in Brazil in 1999 to that in 2001?
Ensure brevity in your answer.  1.04. What is the ratio of the Mortality Rate(per 1000 female or male adults) in Macao in 1999 to that in 2001?
Your answer should be very brief. 1.04. What is the ratio of the Mortality Rate(per 1000 female or male adults) in Pakistan in 1999 to that in 2001?
Give a very brief answer. 1.01. What is the ratio of the Mortality Rate(per 1000 female or male adults) of Brazil in 1999 to that in 2002?
Ensure brevity in your answer.  1.06. What is the ratio of the Mortality Rate(per 1000 female or male adults) of Macao in 1999 to that in 2002?
Make the answer very short. 1.06. What is the ratio of the Mortality Rate(per 1000 female or male adults) in Pakistan in 1999 to that in 2002?
Make the answer very short. 1.02. What is the ratio of the Mortality Rate(per 1000 female or male adults) of Brazil in 1999 to that in 2003?
Provide a succinct answer. 1.08. What is the ratio of the Mortality Rate(per 1000 female or male adults) in Macao in 1999 to that in 2003?
Your answer should be compact. 1.09. What is the ratio of the Mortality Rate(per 1000 female or male adults) of Pakistan in 1999 to that in 2003?
Provide a short and direct response. 1.03. What is the ratio of the Mortality Rate(per 1000 female or male adults) in Brazil in 1999 to that in 2004?
Give a very brief answer. 1.1. What is the ratio of the Mortality Rate(per 1000 female or male adults) of Macao in 1999 to that in 2004?
Ensure brevity in your answer.  1.11. What is the ratio of the Mortality Rate(per 1000 female or male adults) of Pakistan in 1999 to that in 2004?
Your answer should be compact. 1.03. What is the ratio of the Mortality Rate(per 1000 female or male adults) of Brazil in 2000 to that in 2001?
Offer a very short reply. 1.02. What is the ratio of the Mortality Rate(per 1000 female or male adults) in Macao in 2000 to that in 2001?
Offer a very short reply. 1.02. What is the ratio of the Mortality Rate(per 1000 female or male adults) in Pakistan in 2000 to that in 2001?
Give a very brief answer. 1.01. What is the ratio of the Mortality Rate(per 1000 female or male adults) in Brazil in 2000 to that in 2002?
Make the answer very short. 1.04. What is the ratio of the Mortality Rate(per 1000 female or male adults) of Macao in 2000 to that in 2002?
Your answer should be compact. 1.04. What is the ratio of the Mortality Rate(per 1000 female or male adults) in Pakistan in 2000 to that in 2002?
Ensure brevity in your answer.  1.01. What is the ratio of the Mortality Rate(per 1000 female or male adults) of Brazil in 2000 to that in 2003?
Offer a very short reply. 1.06. What is the ratio of the Mortality Rate(per 1000 female or male adults) in Macao in 2000 to that in 2003?
Make the answer very short. 1.06. What is the ratio of the Mortality Rate(per 1000 female or male adults) in Pakistan in 2000 to that in 2003?
Your answer should be very brief. 1.02. What is the ratio of the Mortality Rate(per 1000 female or male adults) of Brazil in 2000 to that in 2004?
Keep it short and to the point. 1.08. What is the ratio of the Mortality Rate(per 1000 female or male adults) of Macao in 2000 to that in 2004?
Offer a very short reply. 1.09. What is the ratio of the Mortality Rate(per 1000 female or male adults) in Pakistan in 2000 to that in 2004?
Ensure brevity in your answer.  1.03. What is the ratio of the Mortality Rate(per 1000 female or male adults) in Brazil in 2001 to that in 2002?
Make the answer very short. 1.02. What is the ratio of the Mortality Rate(per 1000 female or male adults) of Macao in 2001 to that in 2002?
Provide a short and direct response. 1.02. What is the ratio of the Mortality Rate(per 1000 female or male adults) of Brazil in 2001 to that in 2003?
Your response must be concise. 1.04. What is the ratio of the Mortality Rate(per 1000 female or male adults) of Macao in 2001 to that in 2003?
Your response must be concise. 1.04. What is the ratio of the Mortality Rate(per 1000 female or male adults) in Pakistan in 2001 to that in 2003?
Give a very brief answer. 1.01. What is the ratio of the Mortality Rate(per 1000 female or male adults) of Brazil in 2001 to that in 2004?
Make the answer very short. 1.06. What is the ratio of the Mortality Rate(per 1000 female or male adults) in Macao in 2001 to that in 2004?
Provide a succinct answer. 1.06. What is the ratio of the Mortality Rate(per 1000 female or male adults) in Pakistan in 2001 to that in 2004?
Keep it short and to the point. 1.02. What is the ratio of the Mortality Rate(per 1000 female or male adults) of Brazil in 2002 to that in 2003?
Ensure brevity in your answer.  1.02. What is the ratio of the Mortality Rate(per 1000 female or male adults) of Macao in 2002 to that in 2003?
Ensure brevity in your answer.  1.02. What is the ratio of the Mortality Rate(per 1000 female or male adults) of Pakistan in 2002 to that in 2003?
Your response must be concise. 1.01. What is the ratio of the Mortality Rate(per 1000 female or male adults) of Brazil in 2002 to that in 2004?
Ensure brevity in your answer.  1.03. What is the ratio of the Mortality Rate(per 1000 female or male adults) of Macao in 2002 to that in 2004?
Your response must be concise. 1.04. What is the ratio of the Mortality Rate(per 1000 female or male adults) of Pakistan in 2002 to that in 2004?
Give a very brief answer. 1.01. What is the ratio of the Mortality Rate(per 1000 female or male adults) of Brazil in 2003 to that in 2004?
Offer a terse response. 1.02. What is the ratio of the Mortality Rate(per 1000 female or male adults) of Macao in 2003 to that in 2004?
Keep it short and to the point. 1.02. What is the ratio of the Mortality Rate(per 1000 female or male adults) in Pakistan in 2003 to that in 2004?
Give a very brief answer. 1.01. What is the difference between the highest and the second highest Mortality Rate(per 1000 female or male adults) of Brazil?
Keep it short and to the point. 5.13. What is the difference between the highest and the second highest Mortality Rate(per 1000 female or male adults) in Macao?
Offer a terse response. 2.22. What is the difference between the highest and the second highest Mortality Rate(per 1000 female or male adults) in Pakistan?
Ensure brevity in your answer.  1.43. What is the difference between the highest and the lowest Mortality Rate(per 1000 female or male adults) of Brazil?
Ensure brevity in your answer.  33.66. What is the difference between the highest and the lowest Mortality Rate(per 1000 female or male adults) in Macao?
Keep it short and to the point. 15.11. What is the difference between the highest and the lowest Mortality Rate(per 1000 female or male adults) of Pakistan?
Offer a terse response. 9.64. 